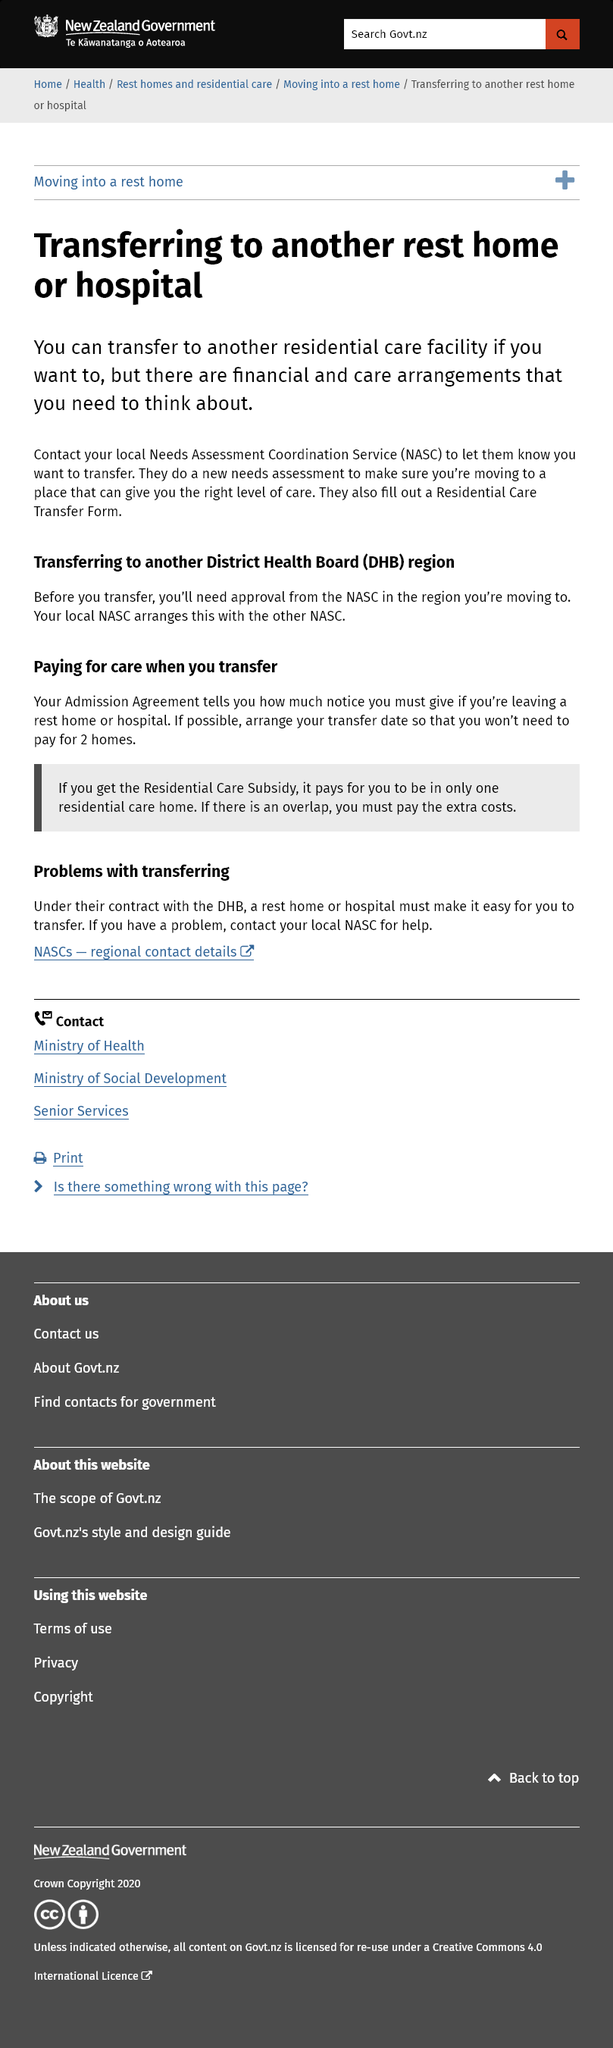Specify some key components in this picture. It is necessary to obtain approval from the National Appeals Standing Committee (NASC) in the region where the transfer will take place before the transfer can be completed. If you wish to transfer to another residential care facility, you should contact your local Needs Assessment Coordination Service (NASC). It is necessary for the NASC to fill out a residential care transfer form in order to transfer. 